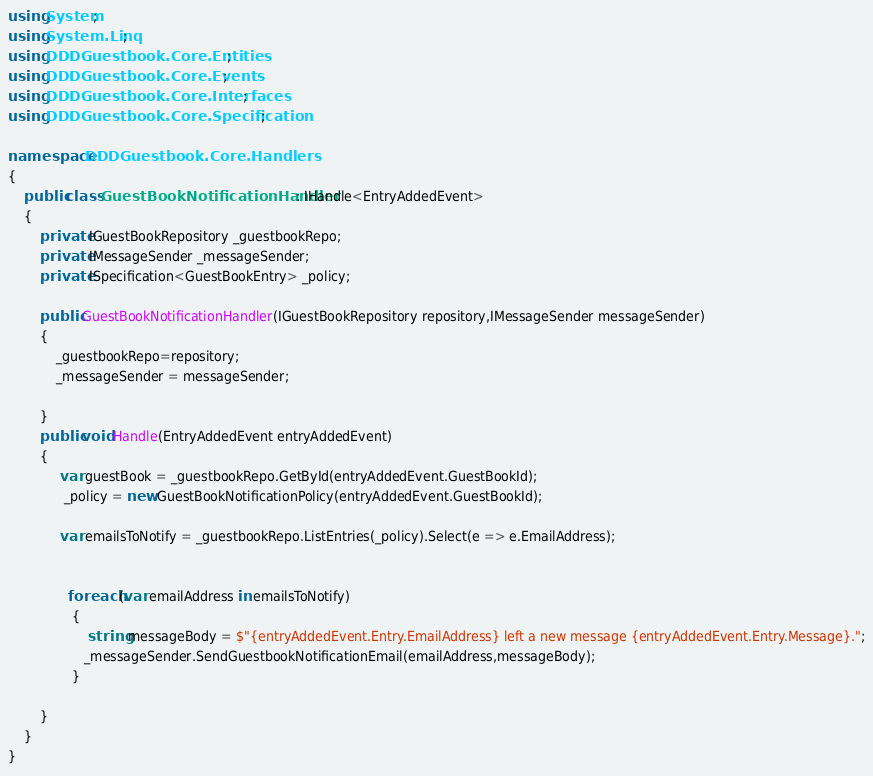<code> <loc_0><loc_0><loc_500><loc_500><_C#_>using System;
using System.Linq;
using DDDGuestbook.Core.Entities;
using DDDGuestbook.Core.Events;
using DDDGuestbook.Core.Interfaces;
using DDDGuestbook.Core.Specification;

namespace DDDGuestbook.Core.Handlers
{
    public class GuestBookNotificationHandler : IHandle<EntryAddedEvent>
    {
        private IGuestBookRepository _guestbookRepo;
        private IMessageSender _messageSender;
        private ISpecification<GuestBookEntry> _policy;

        public GuestBookNotificationHandler(IGuestBookRepository repository,IMessageSender messageSender)
        {
            _guestbookRepo=repository;
            _messageSender = messageSender;
           
        }
        public void Handle(EntryAddedEvent entryAddedEvent)
        {
             var guestBook = _guestbookRepo.GetById(entryAddedEvent.GuestBookId);
              _policy = new GuestBookNotificationPolicy(entryAddedEvent.GuestBookId);

             var emailsToNotify = _guestbookRepo.ListEntries(_policy).Select(e => e.EmailAddress);
               

               foreach (var emailAddress in emailsToNotify)
                {
                    string messageBody = $"{entryAddedEvent.Entry.EmailAddress} left a new message {entryAddedEvent.Entry.Message}.";
                   _messageSender.SendGuestbookNotificationEmail(emailAddress,messageBody);
                }

        }
    }
}</code> 